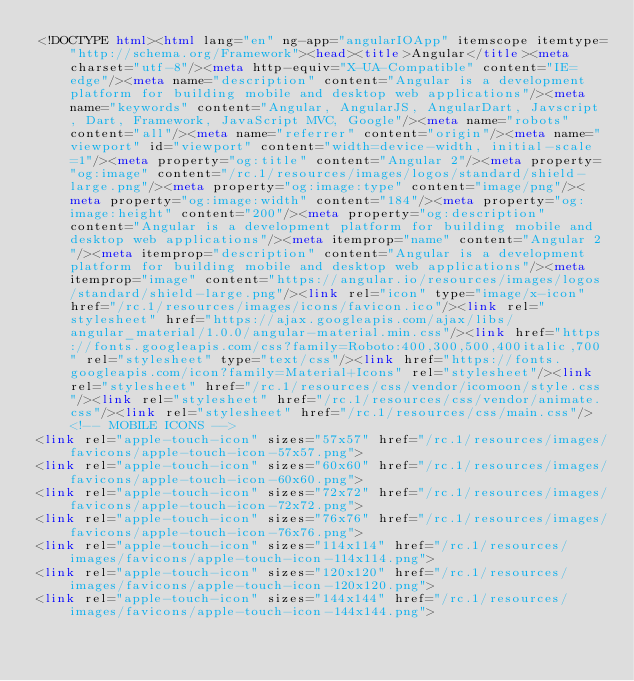Convert code to text. <code><loc_0><loc_0><loc_500><loc_500><_HTML_><!DOCTYPE html><html lang="en" ng-app="angularIOApp" itemscope itemtype="http://schema.org/Framework"><head><title>Angular</title><meta charset="utf-8"/><meta http-equiv="X-UA-Compatible" content="IE=edge"/><meta name="description" content="Angular is a development platform for building mobile and desktop web applications"/><meta name="keywords" content="Angular, AngularJS, AngularDart, Javscript, Dart, Framework, JavaScript MVC, Google"/><meta name="robots" content="all"/><meta name="referrer" content="origin"/><meta name="viewport" id="viewport" content="width=device-width, initial-scale=1"/><meta property="og:title" content="Angular 2"/><meta property="og:image" content="/rc.1/resources/images/logos/standard/shield-large.png"/><meta property="og:image:type" content="image/png"/><meta property="og:image:width" content="184"/><meta property="og:image:height" content="200"/><meta property="og:description" content="Angular is a development platform for building mobile and desktop web applications"/><meta itemprop="name" content="Angular 2"/><meta itemprop="description" content="Angular is a development platform for building mobile and desktop web applications"/><meta itemprop="image" content="https://angular.io/resources/images/logos/standard/shield-large.png"/><link rel="icon" type="image/x-icon" href="/rc.1/resources/images/icons/favicon.ico"/><link rel="stylesheet" href="https://ajax.googleapis.com/ajax/libs/angular_material/1.0.0/angular-material.min.css"/><link href="https://fonts.googleapis.com/css?family=Roboto:400,300,500,400italic,700" rel="stylesheet" type="text/css"/><link href="https://fonts.googleapis.com/icon?family=Material+Icons" rel="stylesheet"/><link rel="stylesheet" href="/rc.1/resources/css/vendor/icomoon/style.css"/><link rel="stylesheet" href="/rc.1/resources/css/vendor/animate.css"/><link rel="stylesheet" href="/rc.1/resources/css/main.css"/><!-- MOBILE ICONS -->
<link rel="apple-touch-icon" sizes="57x57" href="/rc.1/resources/images/favicons/apple-touch-icon-57x57.png">
<link rel="apple-touch-icon" sizes="60x60" href="/rc.1/resources/images/favicons/apple-touch-icon-60x60.png">
<link rel="apple-touch-icon" sizes="72x72" href="/rc.1/resources/images/favicons/apple-touch-icon-72x72.png">
<link rel="apple-touch-icon" sizes="76x76" href="/rc.1/resources/images/favicons/apple-touch-icon-76x76.png">
<link rel="apple-touch-icon" sizes="114x114" href="/rc.1/resources/images/favicons/apple-touch-icon-114x114.png">
<link rel="apple-touch-icon" sizes="120x120" href="/rc.1/resources/images/favicons/apple-touch-icon-120x120.png">
<link rel="apple-touch-icon" sizes="144x144" href="/rc.1/resources/images/favicons/apple-touch-icon-144x144.png"></code> 